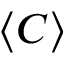Convert formula to latex. <formula><loc_0><loc_0><loc_500><loc_500>\langle C \rangle</formula> 